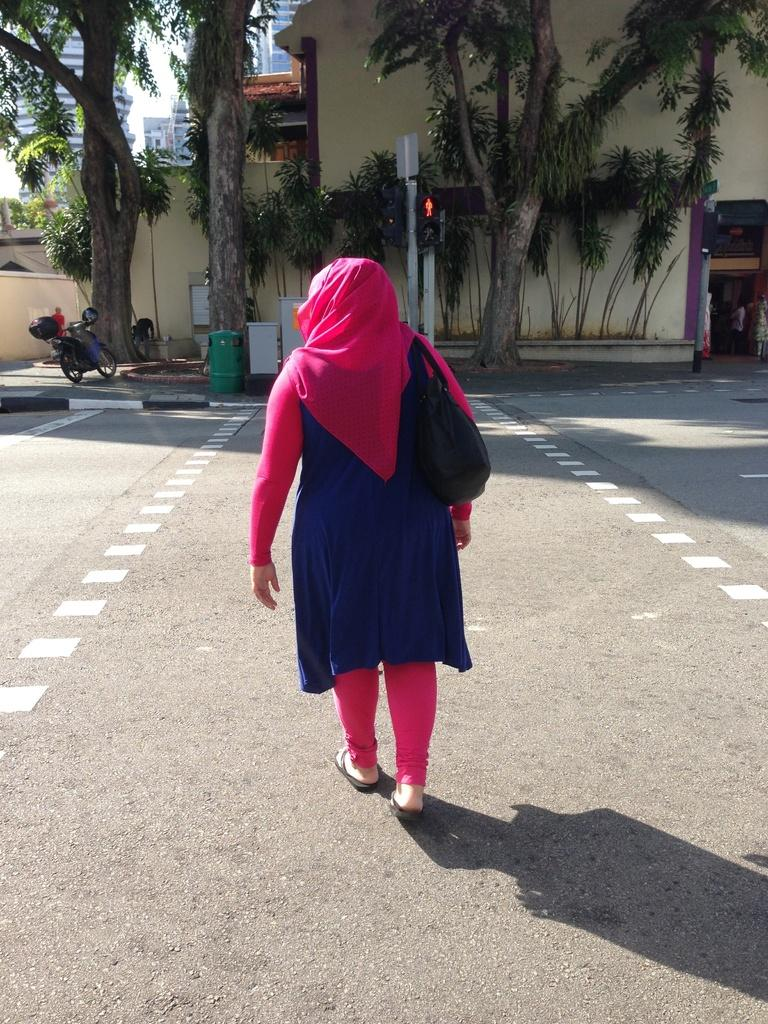What is the person in the image doing? The person is walking in the image. What is the person wearing? The person is wearing a blue and pink dress. What can be seen in the background of the image? There is a vehicle, trees with green leaves, a building with a cream color, and the sky visible in the background of the image. What color is the sky in the image? The sky appears to be white in the image. How many visitors are present in the image? There is no mention of visitors in the image; it only shows a person walking. What type of plants can be seen growing on the building in the image? There are no plants growing on the building in the image; it is a cream-colored building with no visible plants. 